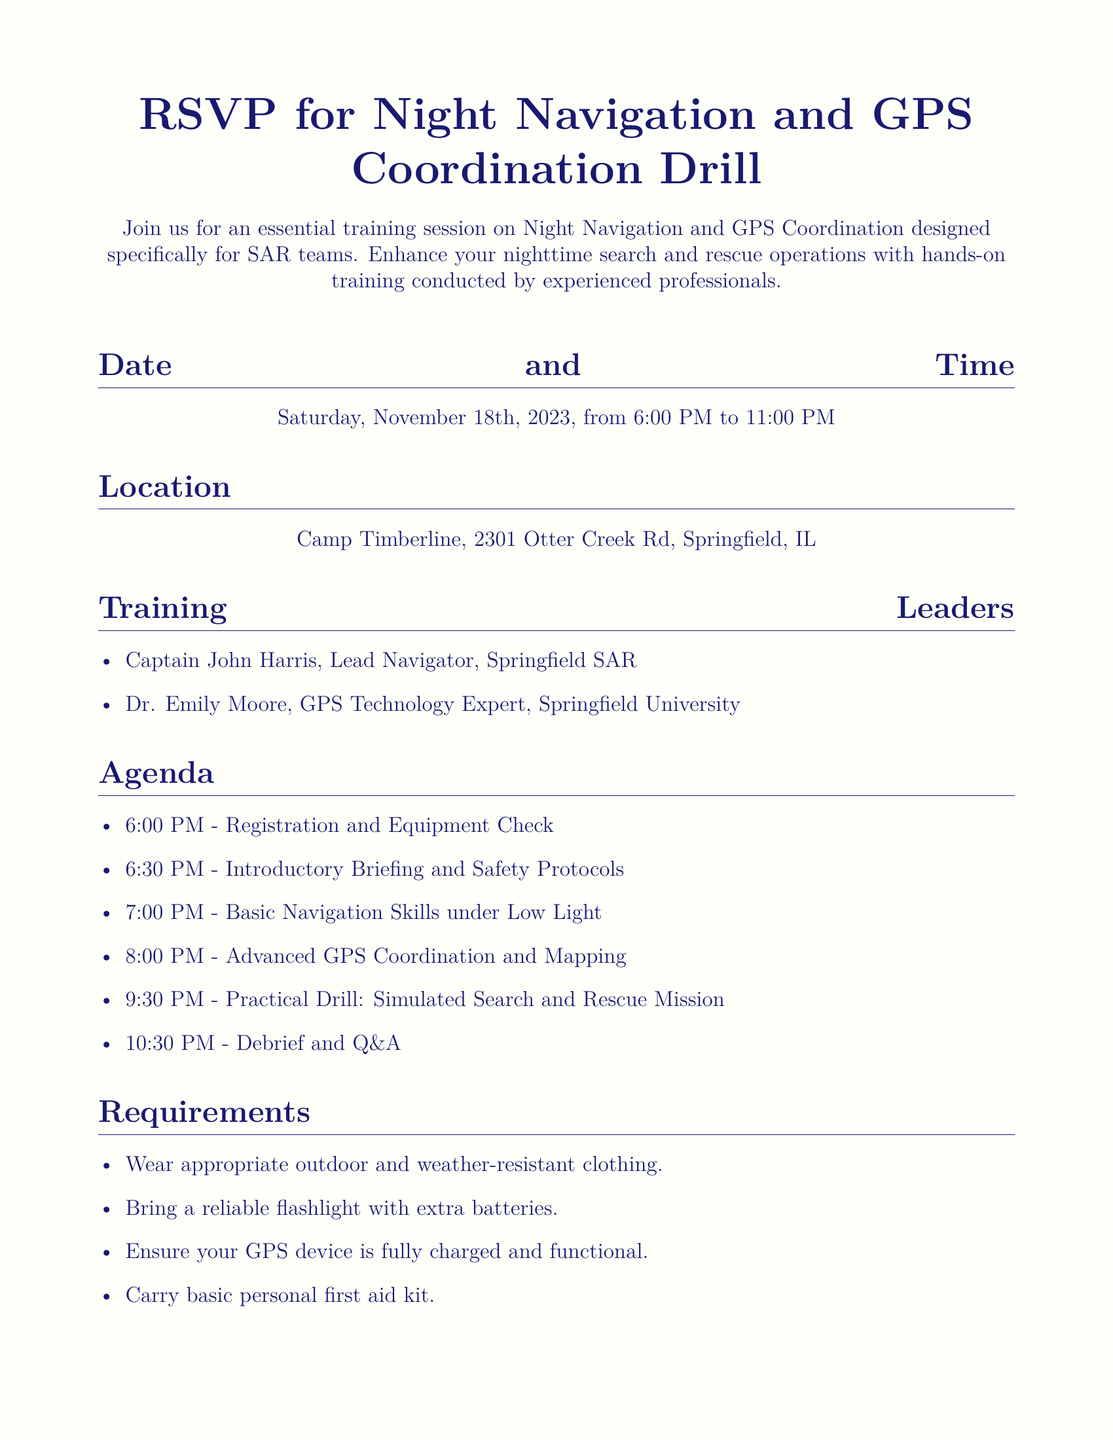What is the date of the event? The event is scheduled for Saturday, November 18th, 2023, as mentioned in the document.
Answer: November 18th, 2023 What time does the training start? The training session begins at 6:00 PM, as listed under the Date and Time section.
Answer: 6:00 PM Where is the event location? The document specifies that the location of the event is Camp Timberline, 2301 Otter Creek Rd, Springfield, IL.
Answer: Camp Timberline, 2301 Otter Creek Rd, Springfield, IL Who is the Lead Navigator? The document identifies Captain John Harris as the Lead Navigator under the Training Leaders section.
Answer: Captain John Harris What is the first agenda item? The first item of the agenda is "Registration and Equipment Check," which can be found in the Agenda section.
Answer: Registration and Equipment Check What should participants bring? Participants are advised to bring a reliable flashlight with extra batteries, which is listed under the Requirements section.
Answer: Reliable flashlight with extra batteries What is the RSVP deadline? The deadline to RSVP is stated as November 10th, 2023, mentioned in the RSVP Details section.
Answer: November 10th, 2023 Who should be contacted for RSVP? The document provides the email sar.training@springfieldrescue.org for RSVPs under RSVP Details.
Answer: sar.training@springfieldrescue.org What type of clothing is required? The document specifies that participants should wear appropriate outdoor and weather-resistant clothing mentioned in the Requirements.
Answer: Appropriate outdoor and weather-resistant clothing 